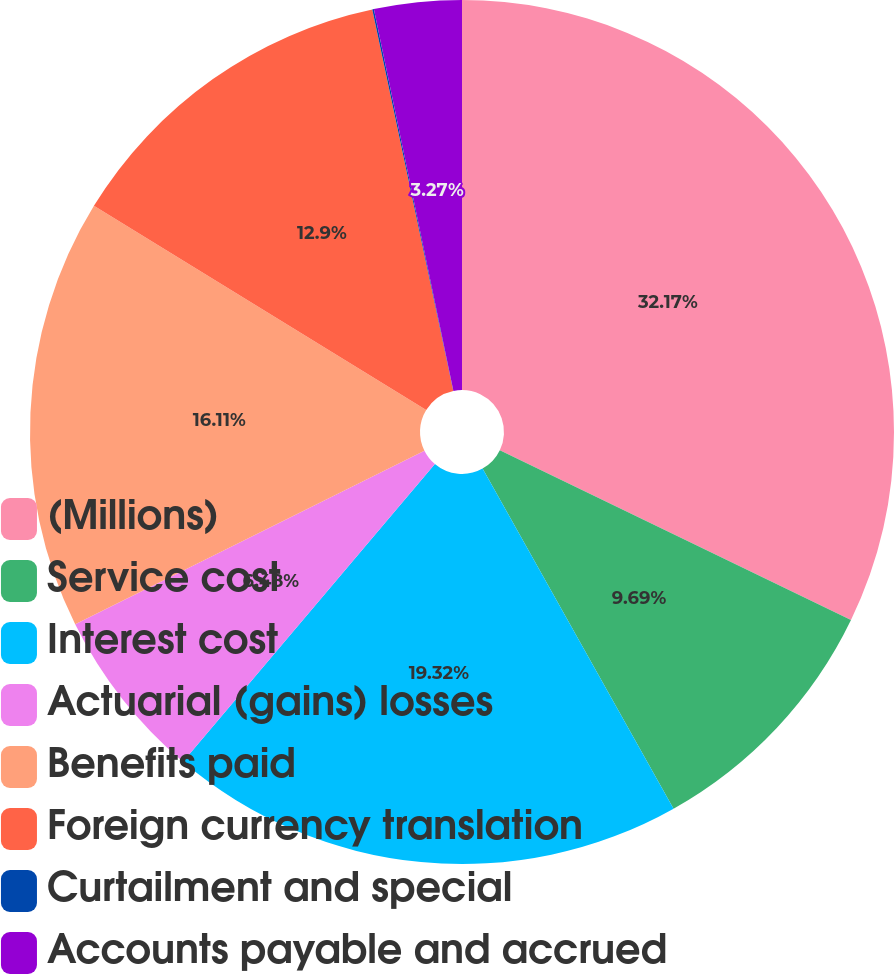Convert chart to OTSL. <chart><loc_0><loc_0><loc_500><loc_500><pie_chart><fcel>(Millions)<fcel>Service cost<fcel>Interest cost<fcel>Actuarial (gains) losses<fcel>Benefits paid<fcel>Foreign currency translation<fcel>Curtailment and special<fcel>Accounts payable and accrued<nl><fcel>32.16%<fcel>9.69%<fcel>19.32%<fcel>6.48%<fcel>16.11%<fcel>12.9%<fcel>0.06%<fcel>3.27%<nl></chart> 